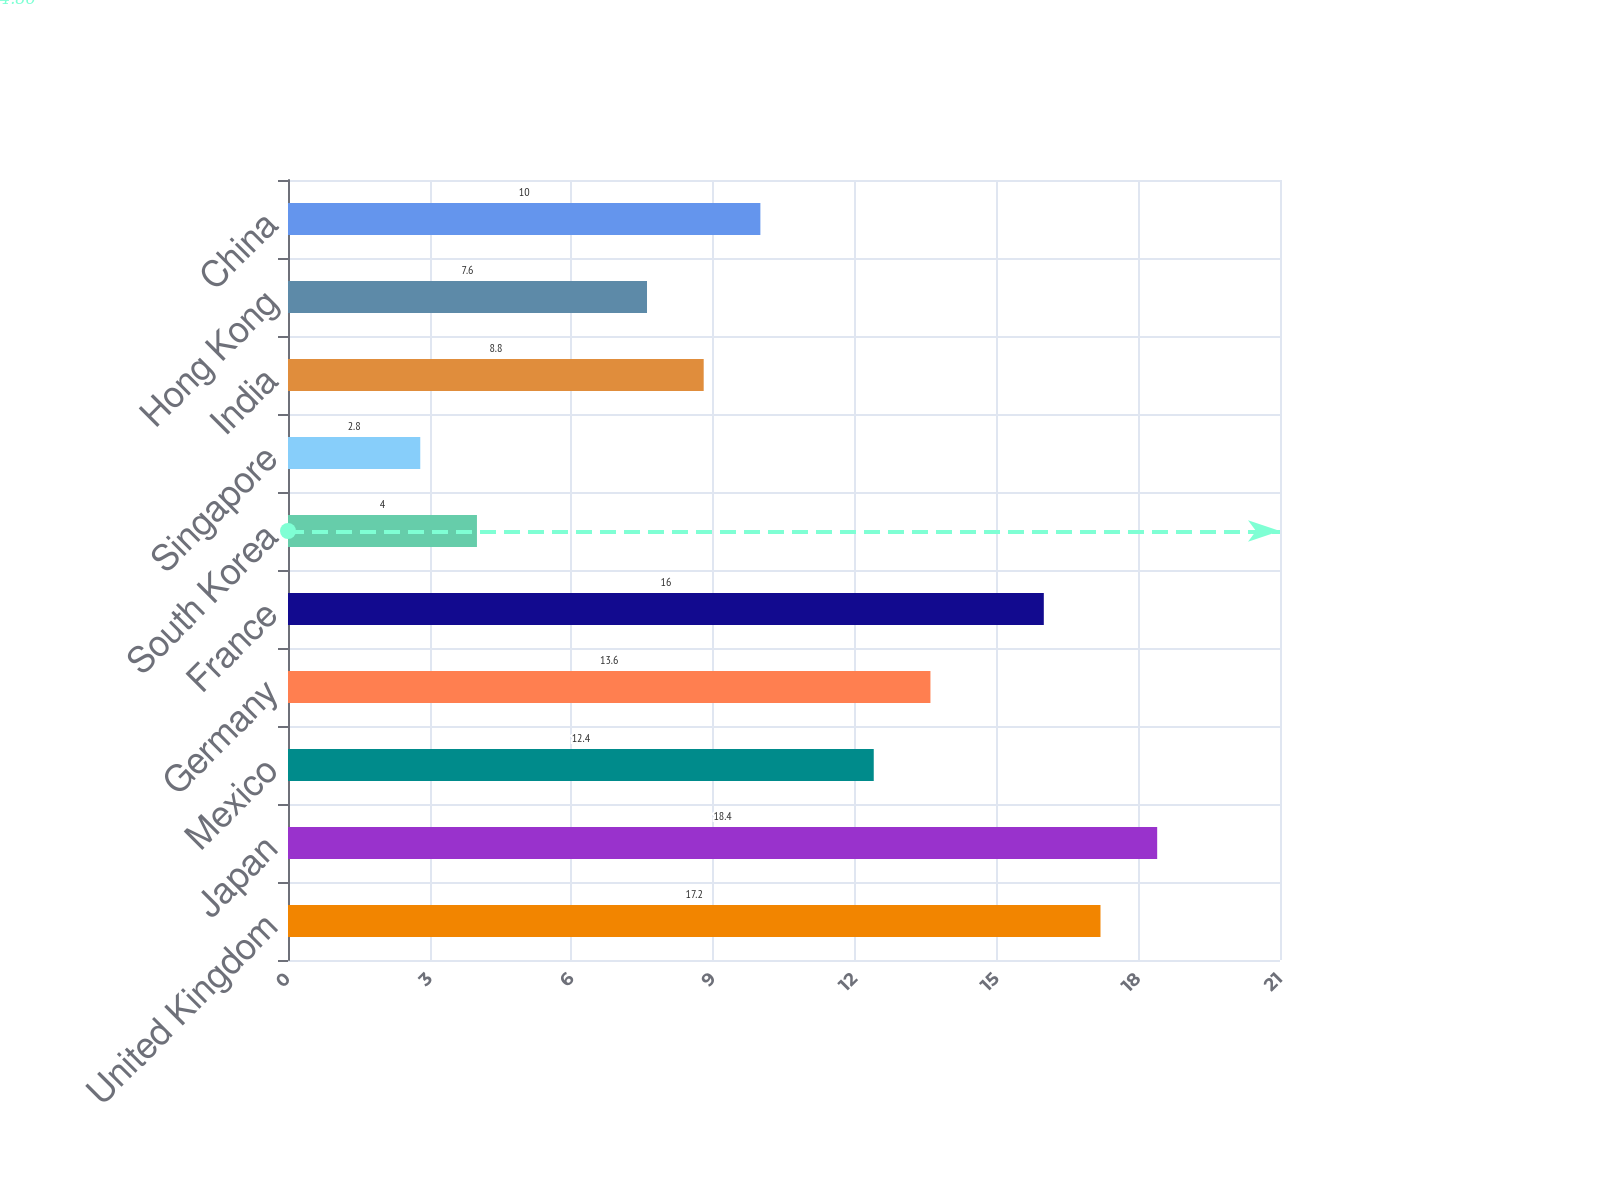<chart> <loc_0><loc_0><loc_500><loc_500><bar_chart><fcel>United Kingdom<fcel>Japan<fcel>Mexico<fcel>Germany<fcel>France<fcel>South Korea<fcel>Singapore<fcel>India<fcel>Hong Kong<fcel>China<nl><fcel>17.2<fcel>18.4<fcel>12.4<fcel>13.6<fcel>16<fcel>4<fcel>2.8<fcel>8.8<fcel>7.6<fcel>10<nl></chart> 